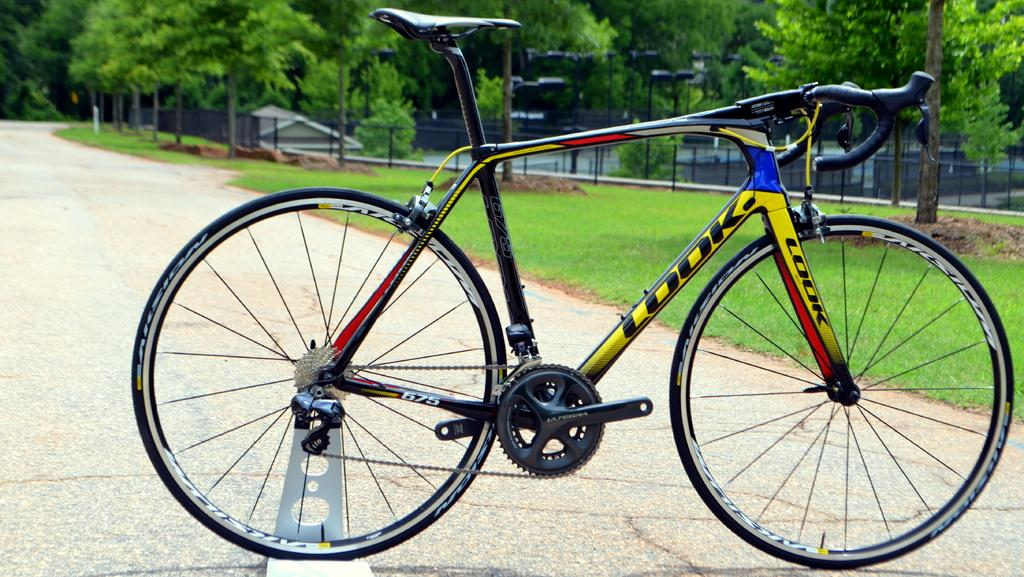What is the main object in the image? There is a bicycle in the image. Can you describe the position of the bicycle? The bicycle is on the ground. What can be seen in the background of the image? There are trees visible in the image. What type of game is being played with the hydrant in the image? There is no hydrant present in the image, and therefore no game involving a hydrant can be observed. 